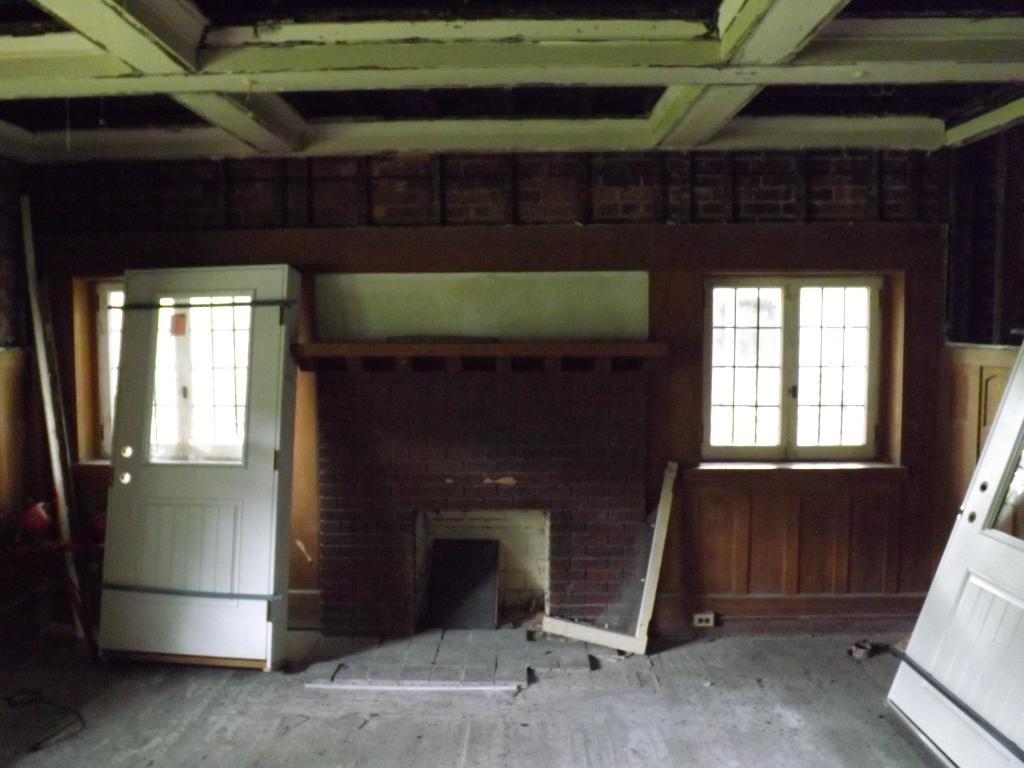Describe this image in one or two sentences. This is inside view of a room. We can see windows, wall, doors, broken object and other objects on the floor. 